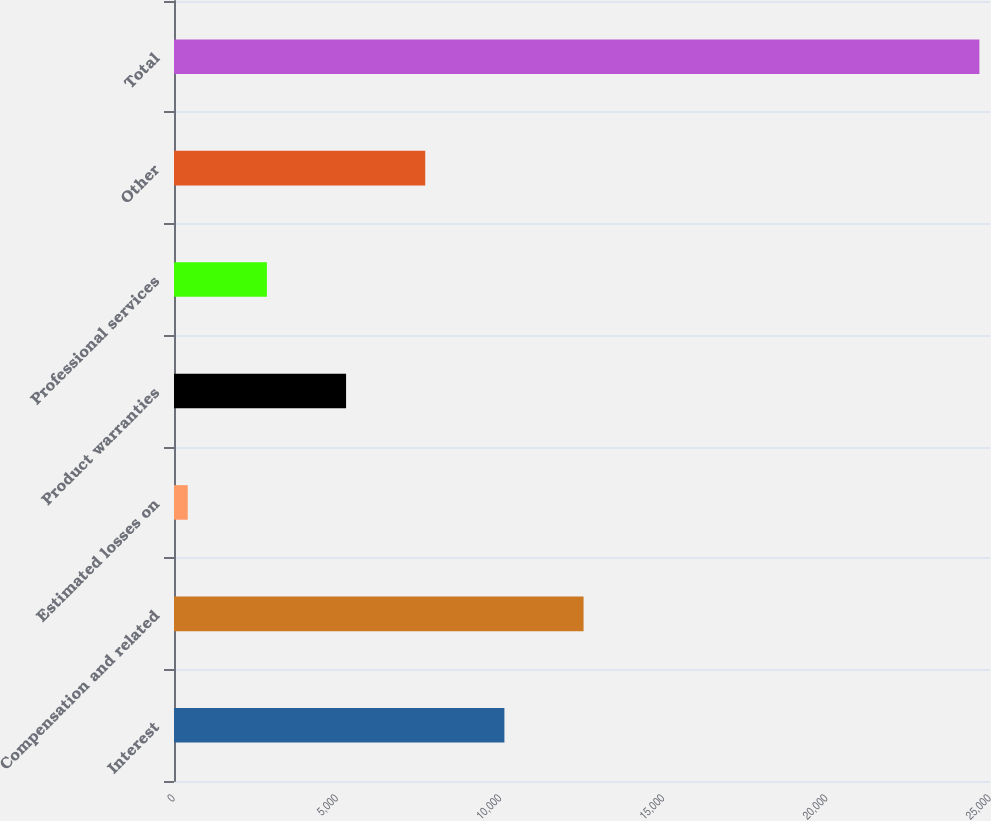Convert chart to OTSL. <chart><loc_0><loc_0><loc_500><loc_500><bar_chart><fcel>Interest<fcel>Compensation and related<fcel>Estimated losses on<fcel>Product warranties<fcel>Professional services<fcel>Other<fcel>Total<nl><fcel>10122.6<fcel>12548<fcel>421<fcel>5271.8<fcel>2846.4<fcel>7697.2<fcel>24675<nl></chart> 